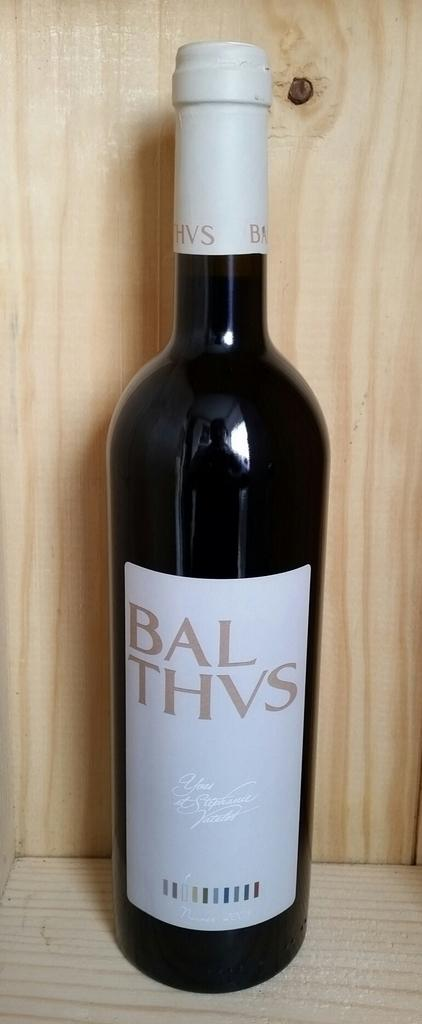Provide a one-sentence caption for the provided image. A bottle is labelled Bal Thvs and has a white label. 